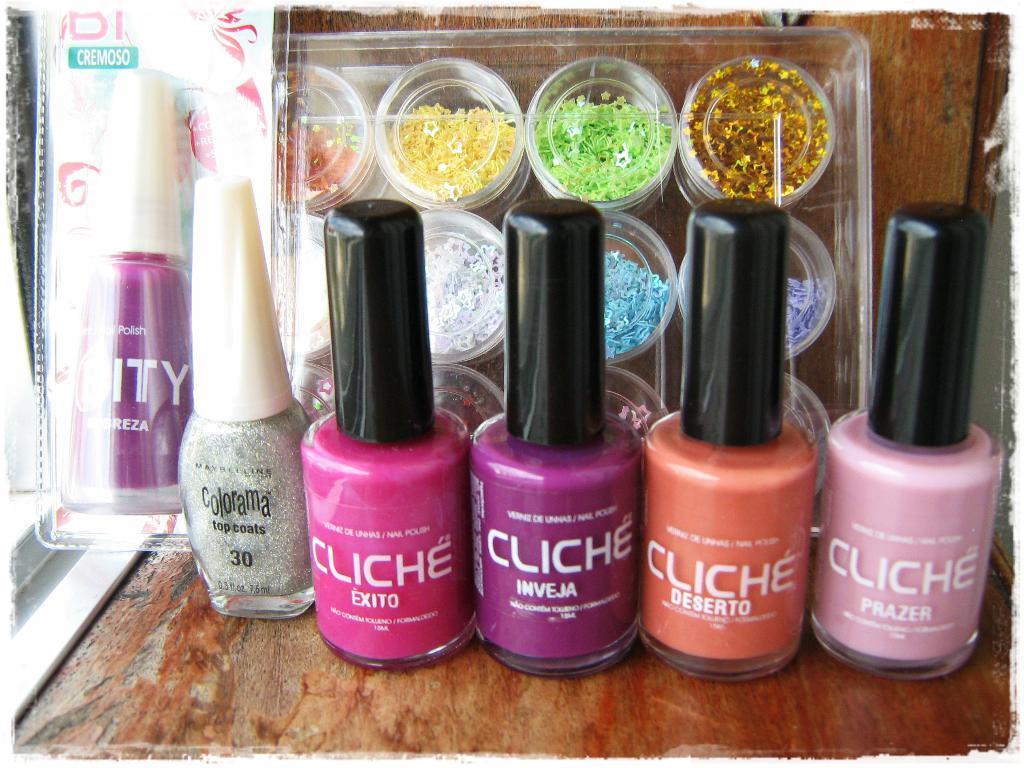Could you give a brief overview of what you see in this image? In this image I can see few bottles of nail paints and on these bottles I can see something is written. I can also see few plastic boxes and in it I can see colourful things. 